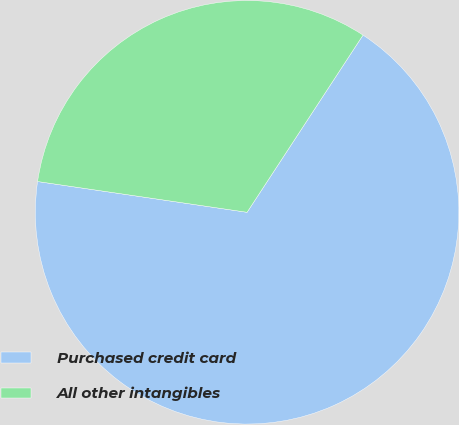Convert chart. <chart><loc_0><loc_0><loc_500><loc_500><pie_chart><fcel>Purchased credit card<fcel>All other intangibles<nl><fcel>68.1%<fcel>31.9%<nl></chart> 